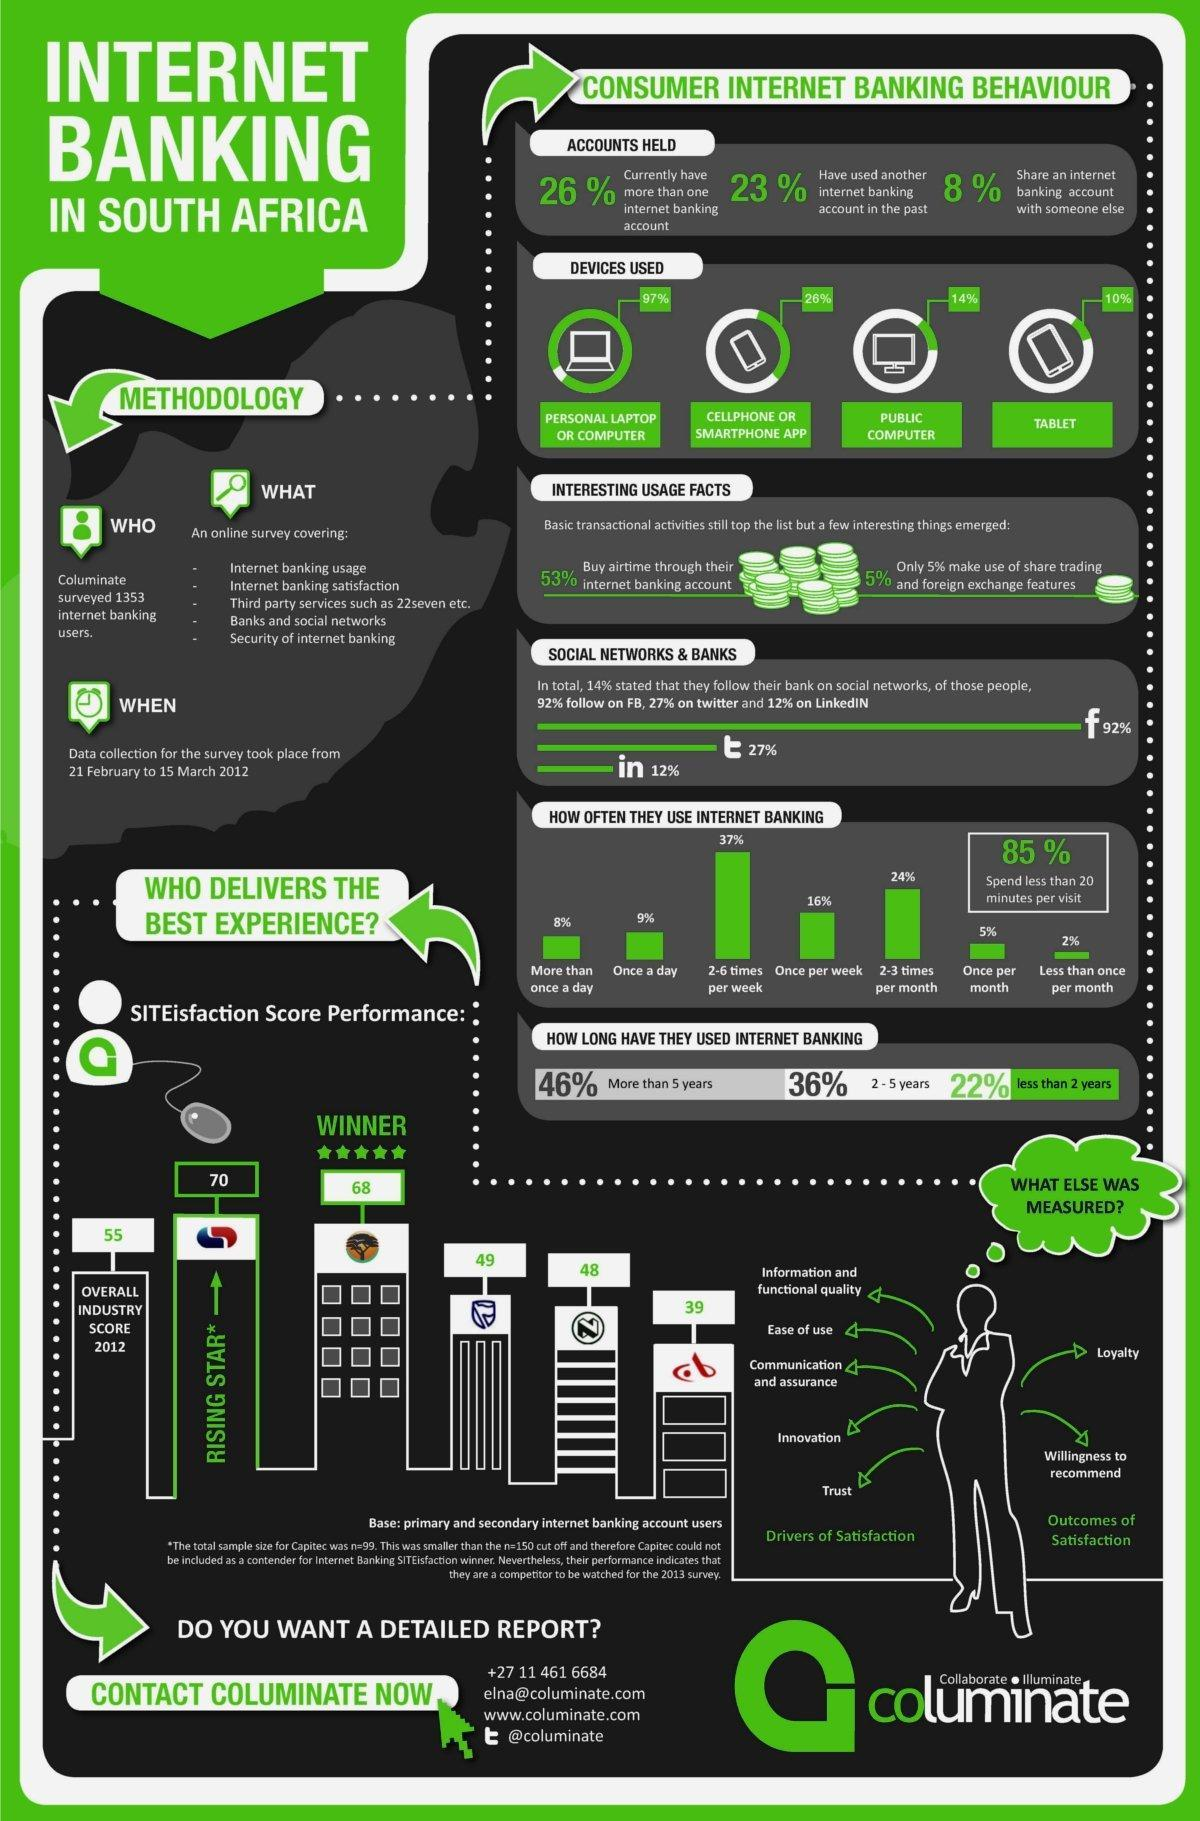What percentage of consumers in South Africa shared an internet banking account with someone else according to the survey in 2012?
Answer the question with a short phrase. 8% Which device is least used by the consumers for internet banking in South Africa as per the survey in 2012? TABLET What percentage of consumers in South Africa use internet banking once per week according to the survey in 2012? 16% What percentage of consumers in South Africa use internet banking once per month according to the survey in 2012? 5% What is the satisfaction score performance of Capitec Bank in South Africa in 2012? 70 What percentage of consumers in South Africa do internet banking using the smartphone app according to the survey in 2012? 26% Which device is used most widely by the internet banking users in South Africa as per the survey in 2012? PERSONAL LAPTOP OR COMPUTER 